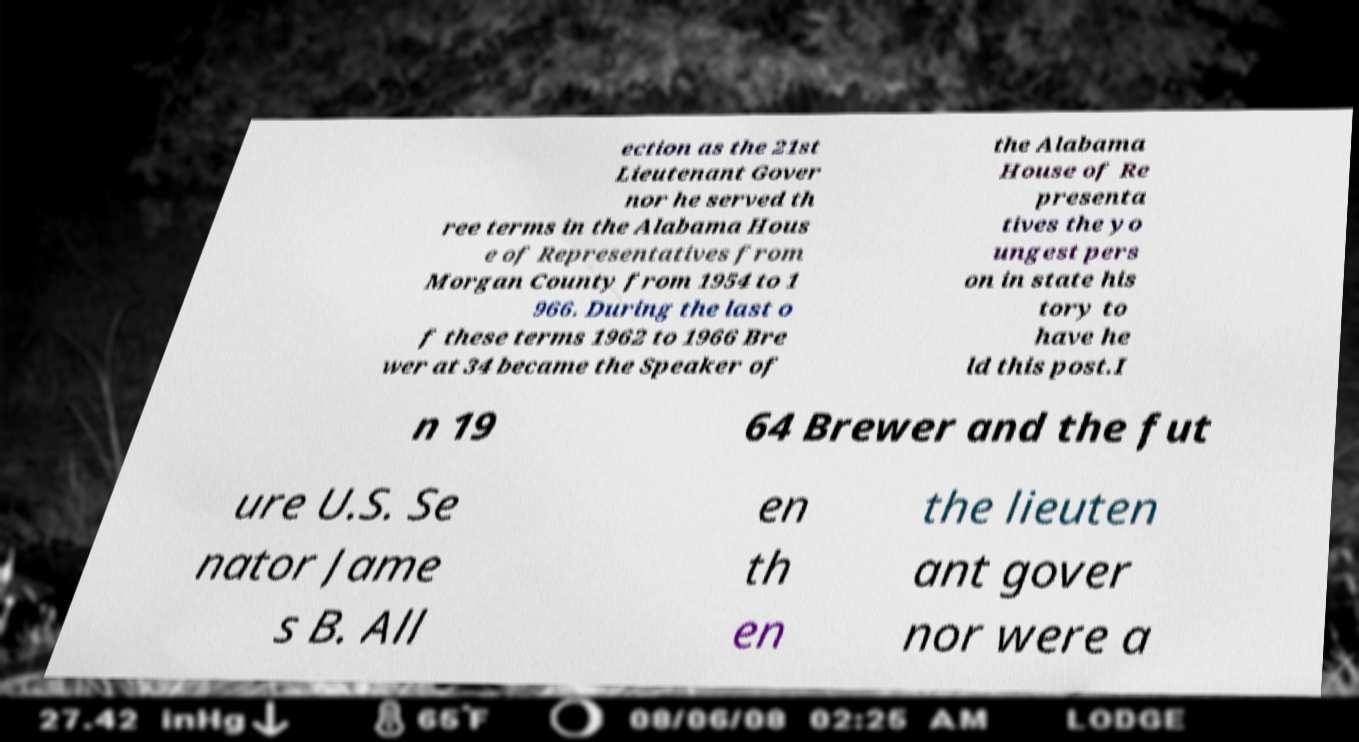Please identify and transcribe the text found in this image. ection as the 21st Lieutenant Gover nor he served th ree terms in the Alabama Hous e of Representatives from Morgan County from 1954 to 1 966. During the last o f these terms 1962 to 1966 Bre wer at 34 became the Speaker of the Alabama House of Re presenta tives the yo ungest pers on in state his tory to have he ld this post.I n 19 64 Brewer and the fut ure U.S. Se nator Jame s B. All en th en the lieuten ant gover nor were a 